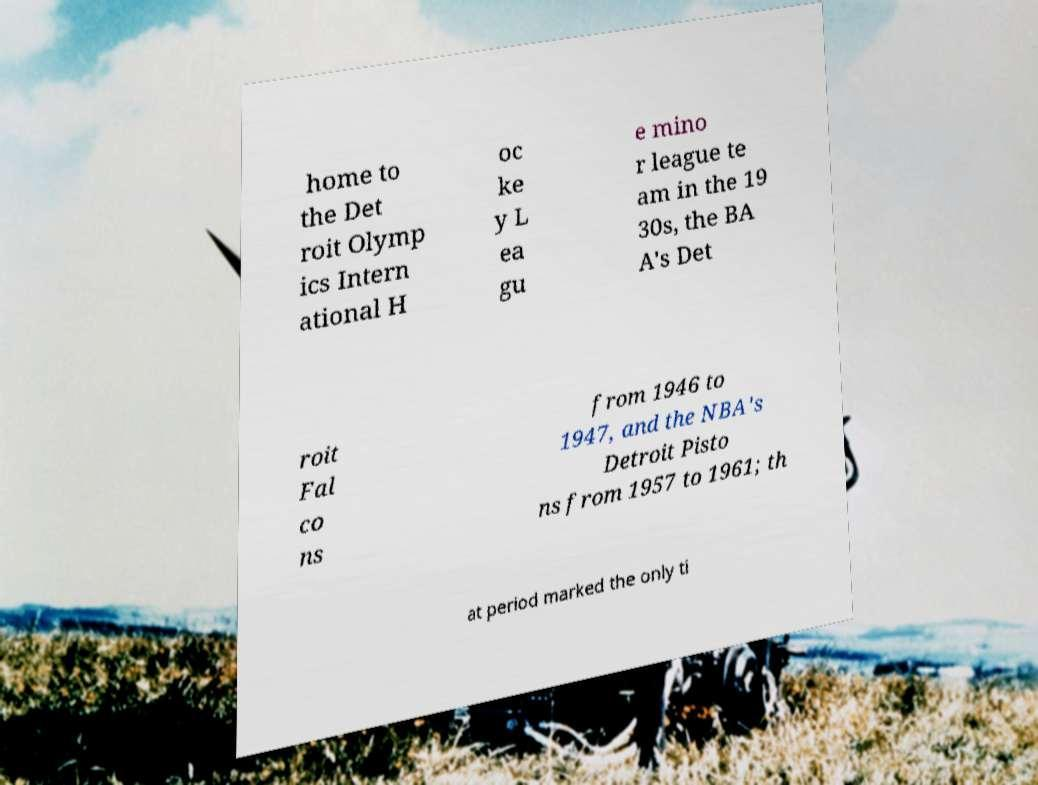Could you extract and type out the text from this image? home to the Det roit Olymp ics Intern ational H oc ke y L ea gu e mino r league te am in the 19 30s, the BA A's Det roit Fal co ns from 1946 to 1947, and the NBA's Detroit Pisto ns from 1957 to 1961; th at period marked the only ti 